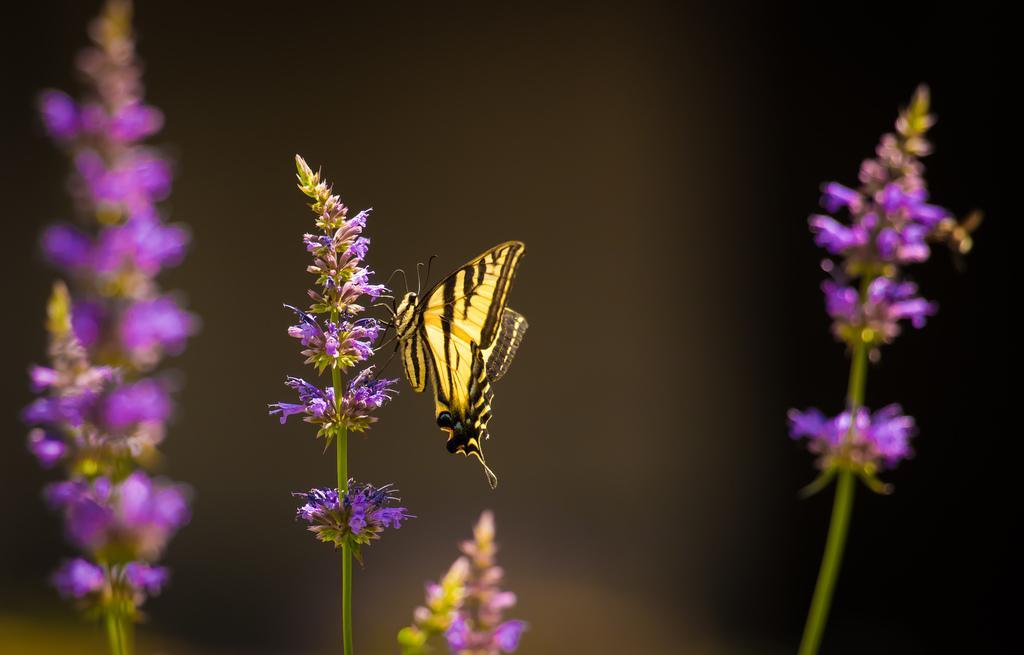Could you give a brief overview of what you see in this image? In this image, we can see some stems of the plants, there are some small purple color flowers, there is a yellow and black color butterfly on the flower, there is a dark background. 